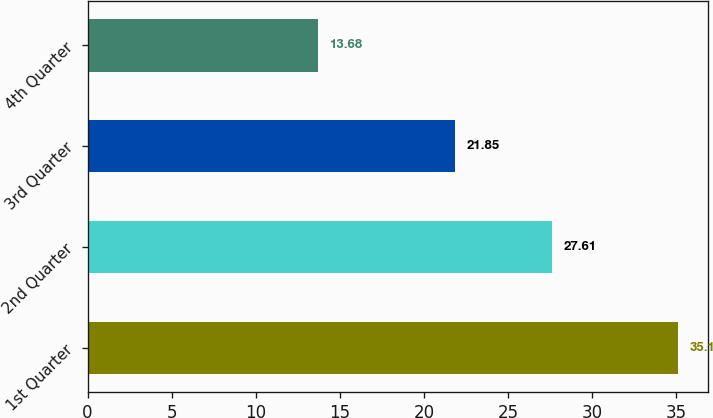<chart> <loc_0><loc_0><loc_500><loc_500><bar_chart><fcel>1st Quarter<fcel>2nd Quarter<fcel>3rd Quarter<fcel>4th Quarter<nl><fcel>35.1<fcel>27.61<fcel>21.85<fcel>13.68<nl></chart> 